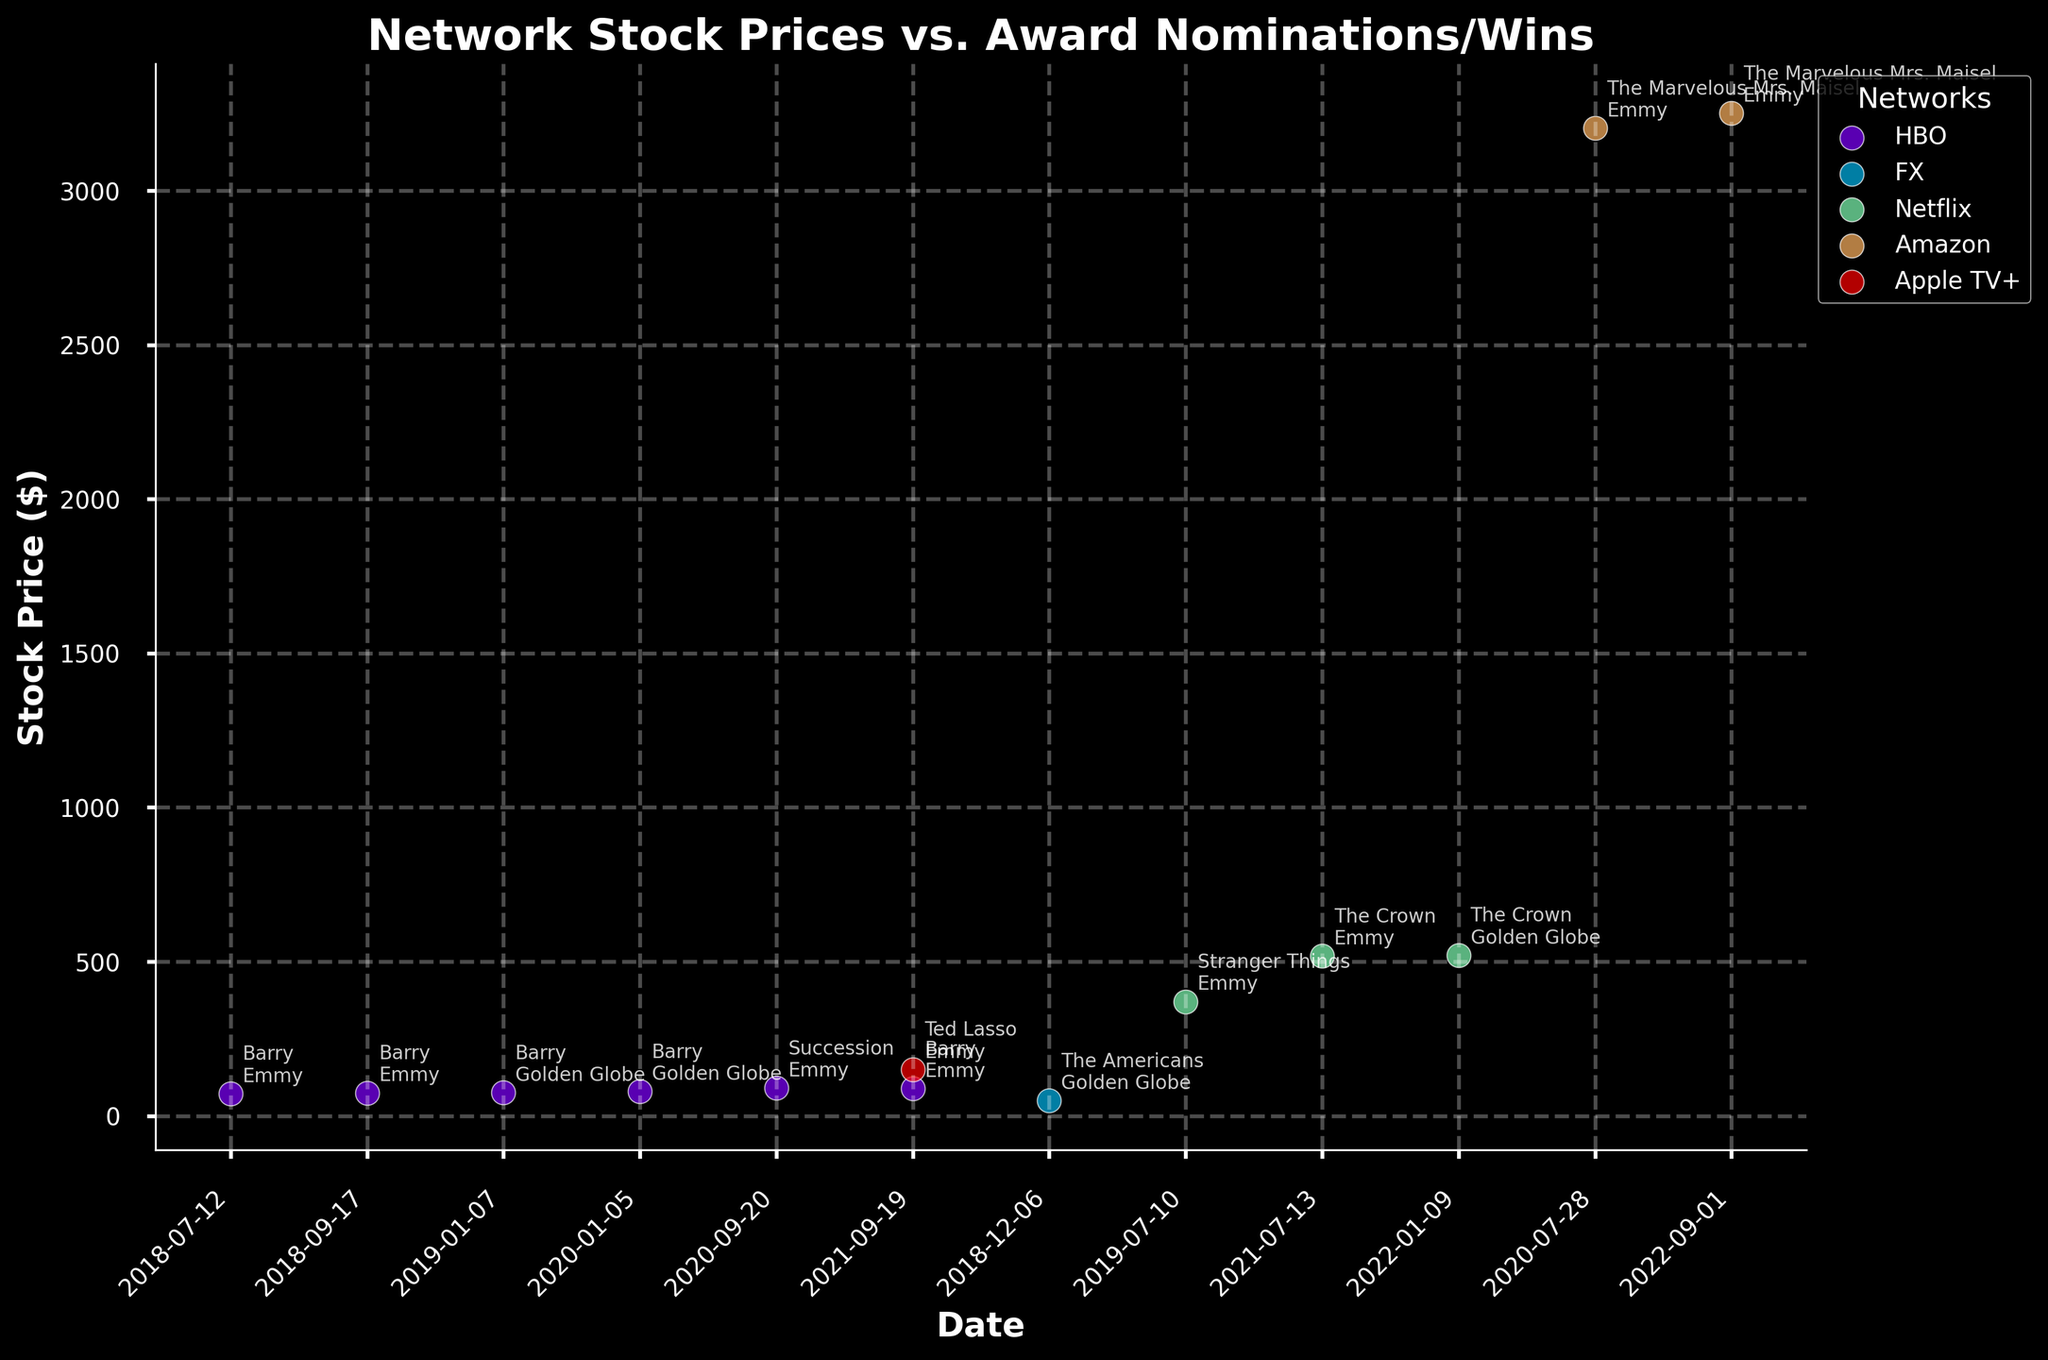What is the highest stock price observed in the plot? By looking at the y-axis that indicates stock prices and the plotted points, the highest stock price is visible next to the date and annotation. It is associated with "The Marvelous Mrs. Maisel" by Amazon.
Answer: 3250.75 Which network shows the greatest increase in stock price after an award event? Comparing each network’s stock prices before and after an award event. For example, comparing HBO's stock prices or Netflix's stock prices before and after key award dates, Amazon's stock price increased from 3203.12 to 3250.75 after "The Marvelous Mrs. Maisel" won 4 Emmys.
Answer: Amazon How many TV shows from Netflix are included in the plot? Reviewing the plot and counting the number of distinct TV show names under the Netflix annotation. Based on the visual observation, there are annotations for "Stranger Things" and "The Crown".
Answer: 2 What was the stock price of HBO when "Barry" received 13 Emmy nominations in 2018-07-12? By looking at the plot annotation for "Barry" and the date 2018-07-12, cross-reference with the stock price marked on y-axis. The stock price corresponds to that date.
Answer: 72.15 Compare HBO and Netflix in terms of the highest stock price achieved after a TV show award event. Which network performed better? Identify the highest stock prices of HBO and Netflix from the plot after their TV show awards, such as HBO's highest after events involving "Barry" and "Succession" versus Netflix's highest involving "Stranger Things" and "The Crown." Netflix's highest stock price, 520.65, is higher than HBO's highest stock price, 90.00.
Answer: Netflix By how much did the stock price of HBO increase from when "Barry" received 13 Emmy nominations in July 2018 to winning 2 Emmys in September 2021? Calculate the difference between HBO's stock price in July 2018 (72.15) and September 2021 (88.25). The increase is given by 88.25 - 72.15.
Answer: 16.10 When did "Ted Lasso" by Apple TV+ appear in the chart and what was the stock price? Locate the date and stock price next to the annotation for "Ted Lasso" by following the date and price annotations along the x and y axes. It appears on 2021-09-19 with a stock price next to the label.
Answer: 150.10 What is the average stock price of HBO over the listed dates? List the stock prices of HBO (72.15, 74.25, 75.50, 78.30, 90.00, 88.25), sum them up (478.45) and divide by the number of points (6) to obtain the average. 478.45/6 = 79.74.
Answer: 79.74 